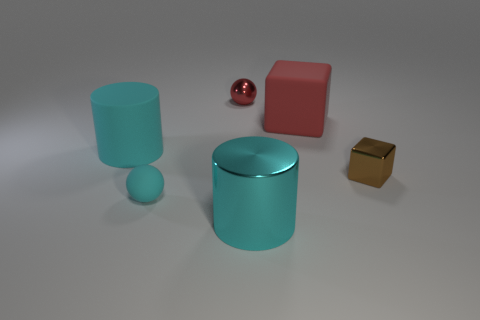Add 4 big yellow objects. How many objects exist? 10 Subtract all cylinders. How many objects are left? 4 Subtract 0 green cylinders. How many objects are left? 6 Subtract all small metallic cubes. Subtract all small brown shiny cylinders. How many objects are left? 5 Add 4 large rubber things. How many large rubber things are left? 6 Add 3 large purple rubber objects. How many large purple rubber objects exist? 3 